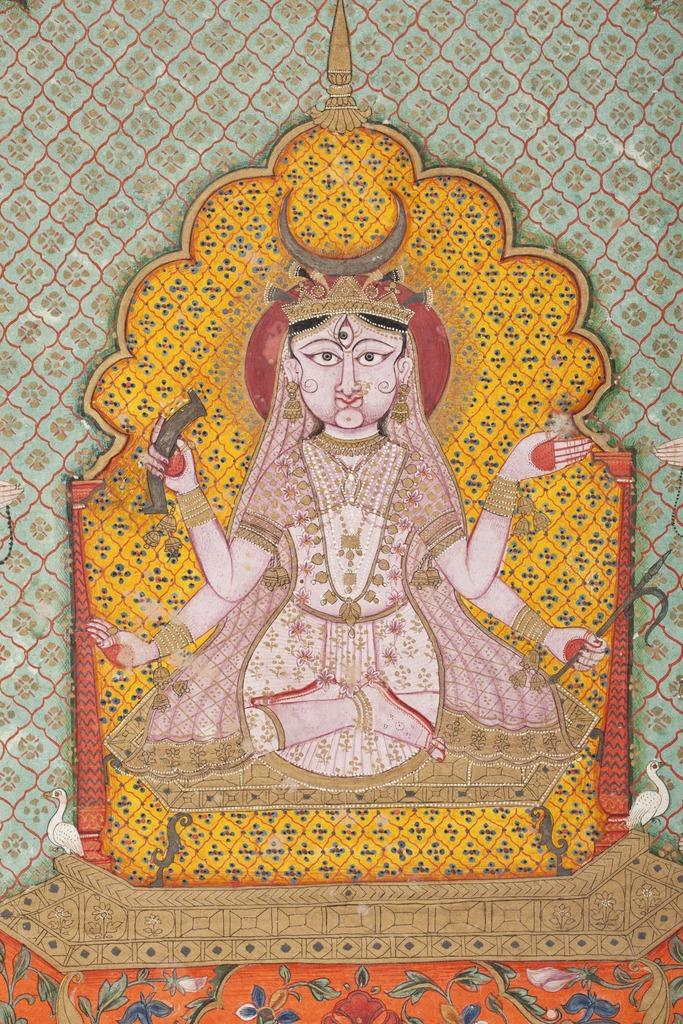What is depicted in the image? There is a picture of a goddess in the image. Where might the picture of the goddess be located? The picture of the goddess might be on a wall or on a stone. What type of wine is being served on the road in the image? There is no wine or road present in the image; it features a picture of a goddess. How many mice can be seen interacting with the goddess in the image? There are no mice present in the image. 